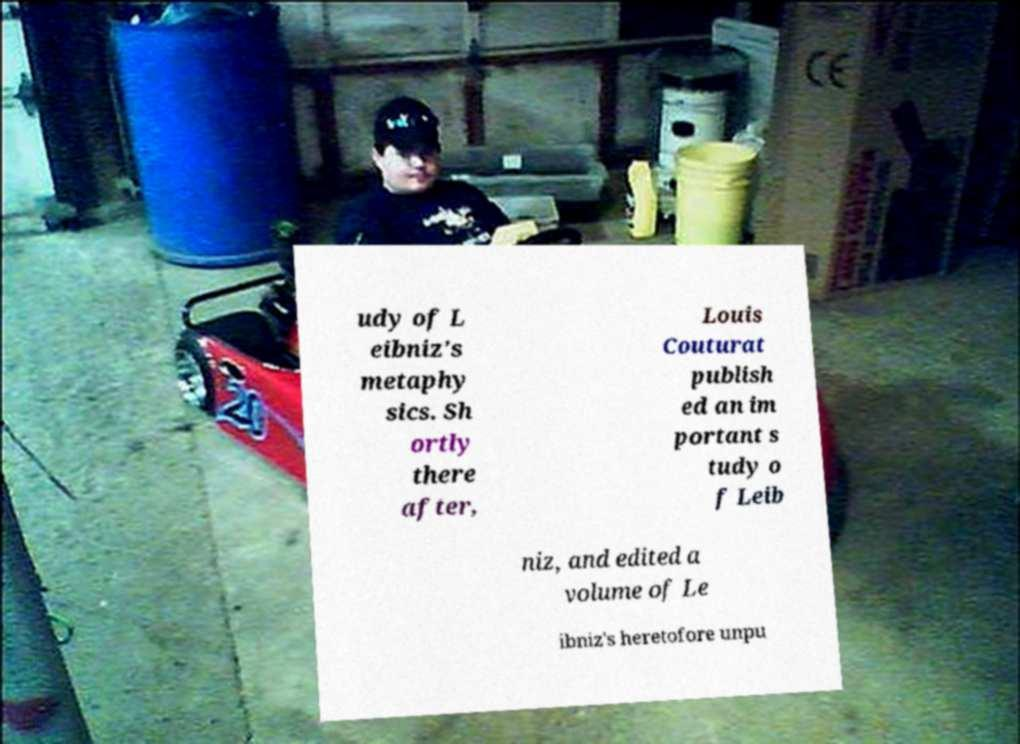Please identify and transcribe the text found in this image. udy of L eibniz's metaphy sics. Sh ortly there after, Louis Couturat publish ed an im portant s tudy o f Leib niz, and edited a volume of Le ibniz's heretofore unpu 